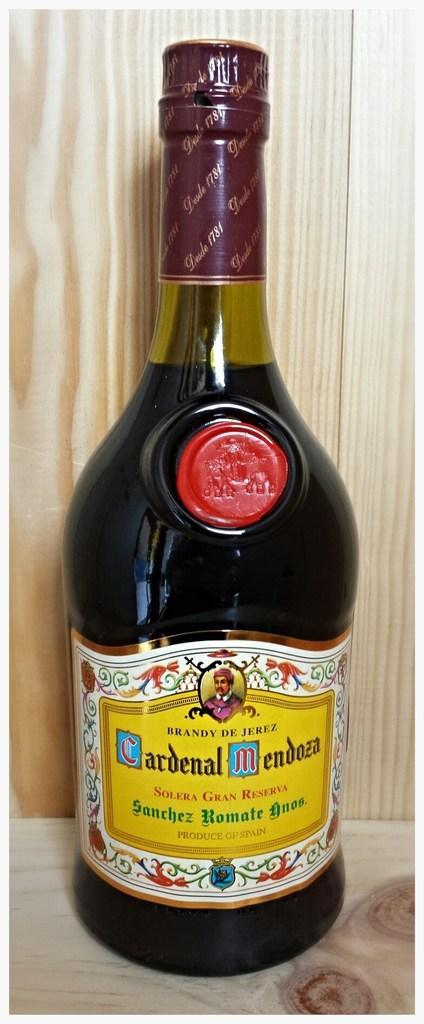In one or two sentences, can you explain what this image depicts? In this picture there is a bottle named Cardinal Mendosa. The bottle is beautifully packed and placed on a wooden table. 